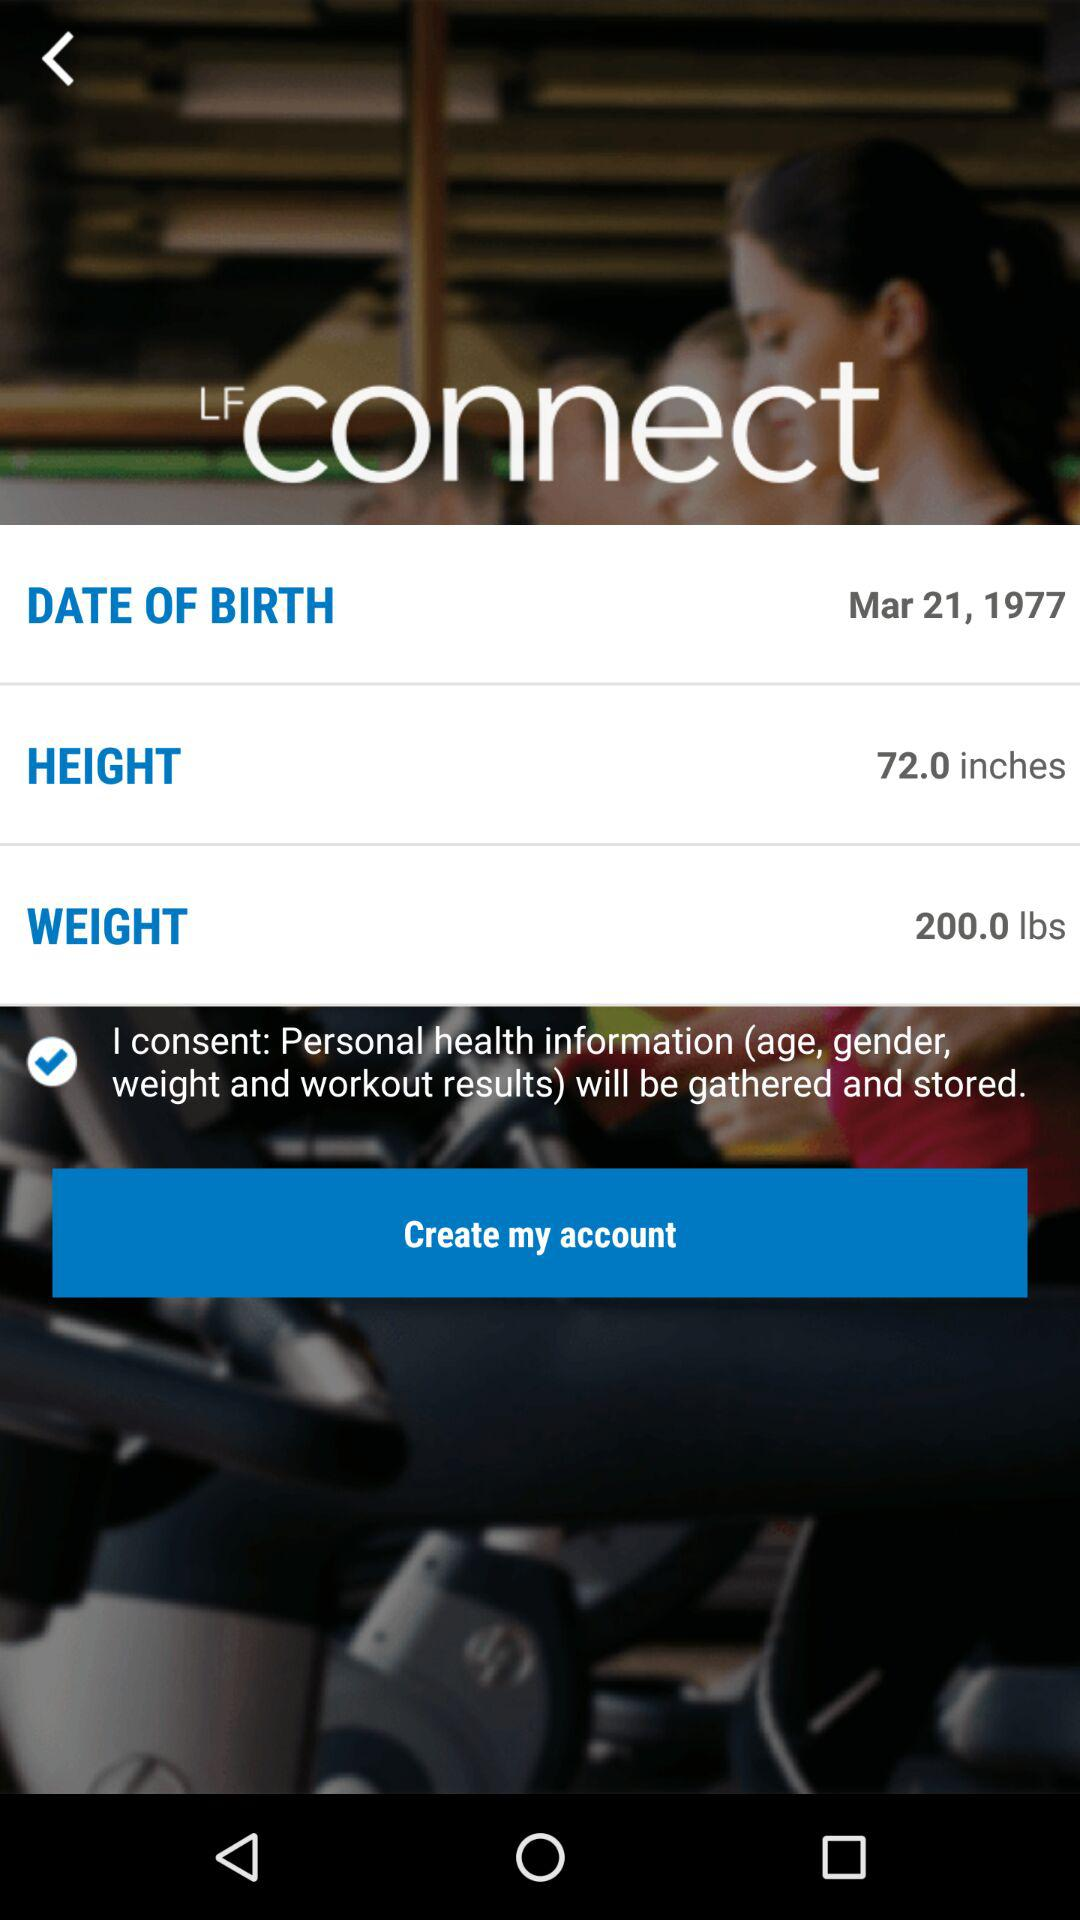What is the weight? The weight is 200.0 lbs. 